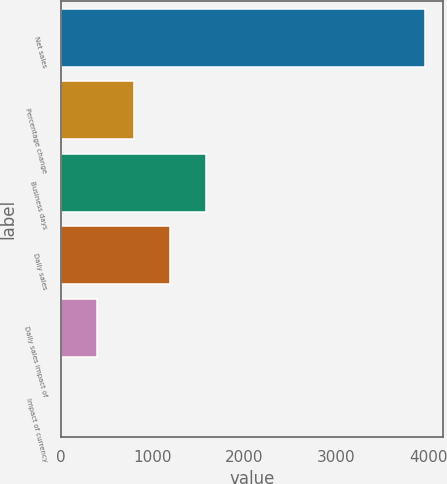Convert chart to OTSL. <chart><loc_0><loc_0><loc_500><loc_500><bar_chart><fcel>Net sales<fcel>Percentage change<fcel>Business days<fcel>Daily sales<fcel>Daily sales impact of<fcel>Impact of currency<nl><fcel>3962<fcel>792.72<fcel>1585.04<fcel>1188.88<fcel>396.56<fcel>0.4<nl></chart> 